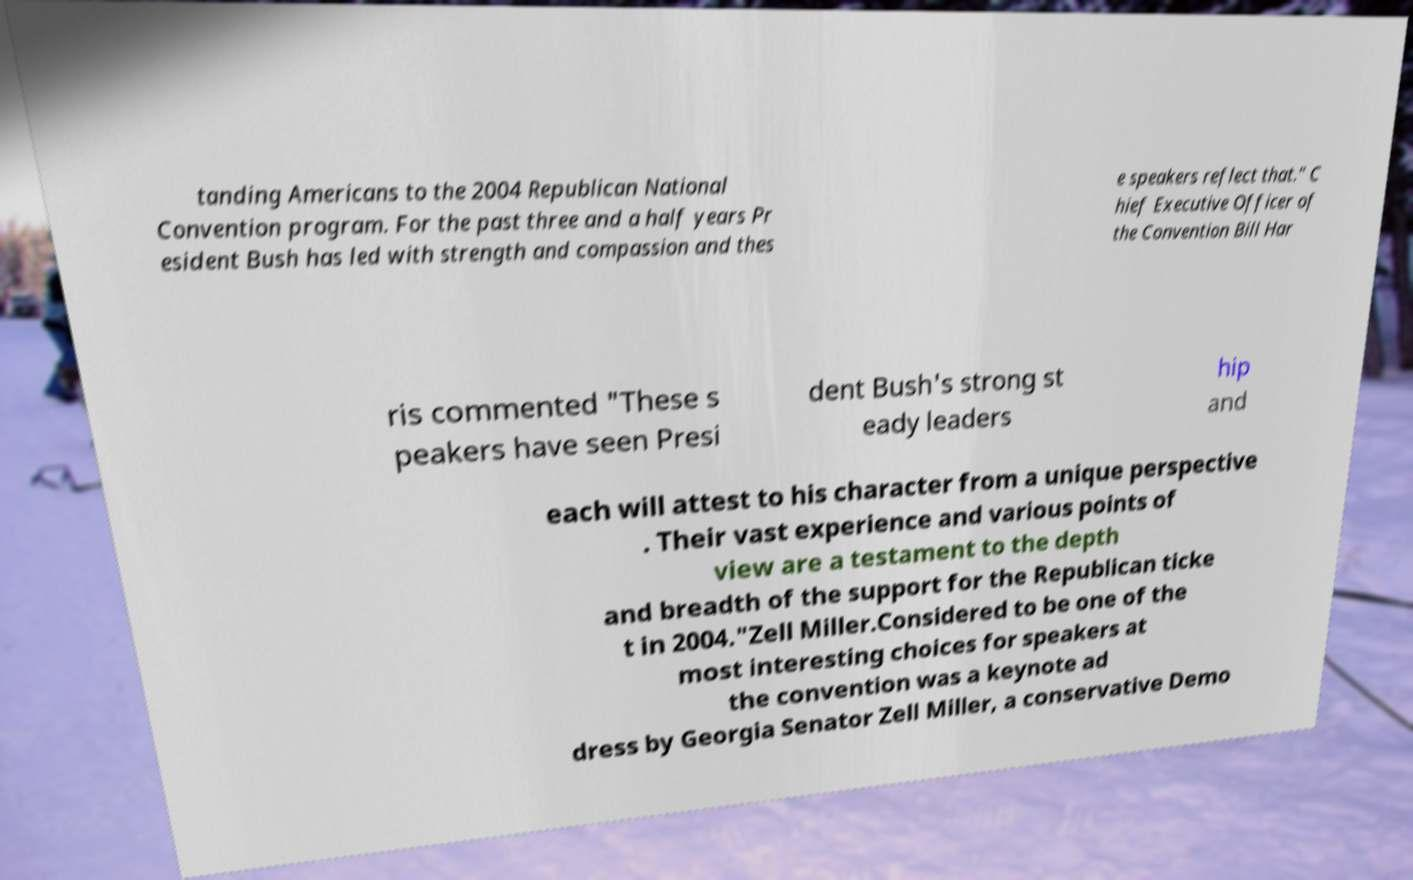What messages or text are displayed in this image? I need them in a readable, typed format. tanding Americans to the 2004 Republican National Convention program. For the past three and a half years Pr esident Bush has led with strength and compassion and thes e speakers reflect that." C hief Executive Officer of the Convention Bill Har ris commented "These s peakers have seen Presi dent Bush's strong st eady leaders hip and each will attest to his character from a unique perspective . Their vast experience and various points of view are a testament to the depth and breadth of the support for the Republican ticke t in 2004."Zell Miller.Considered to be one of the most interesting choices for speakers at the convention was a keynote ad dress by Georgia Senator Zell Miller, a conservative Demo 